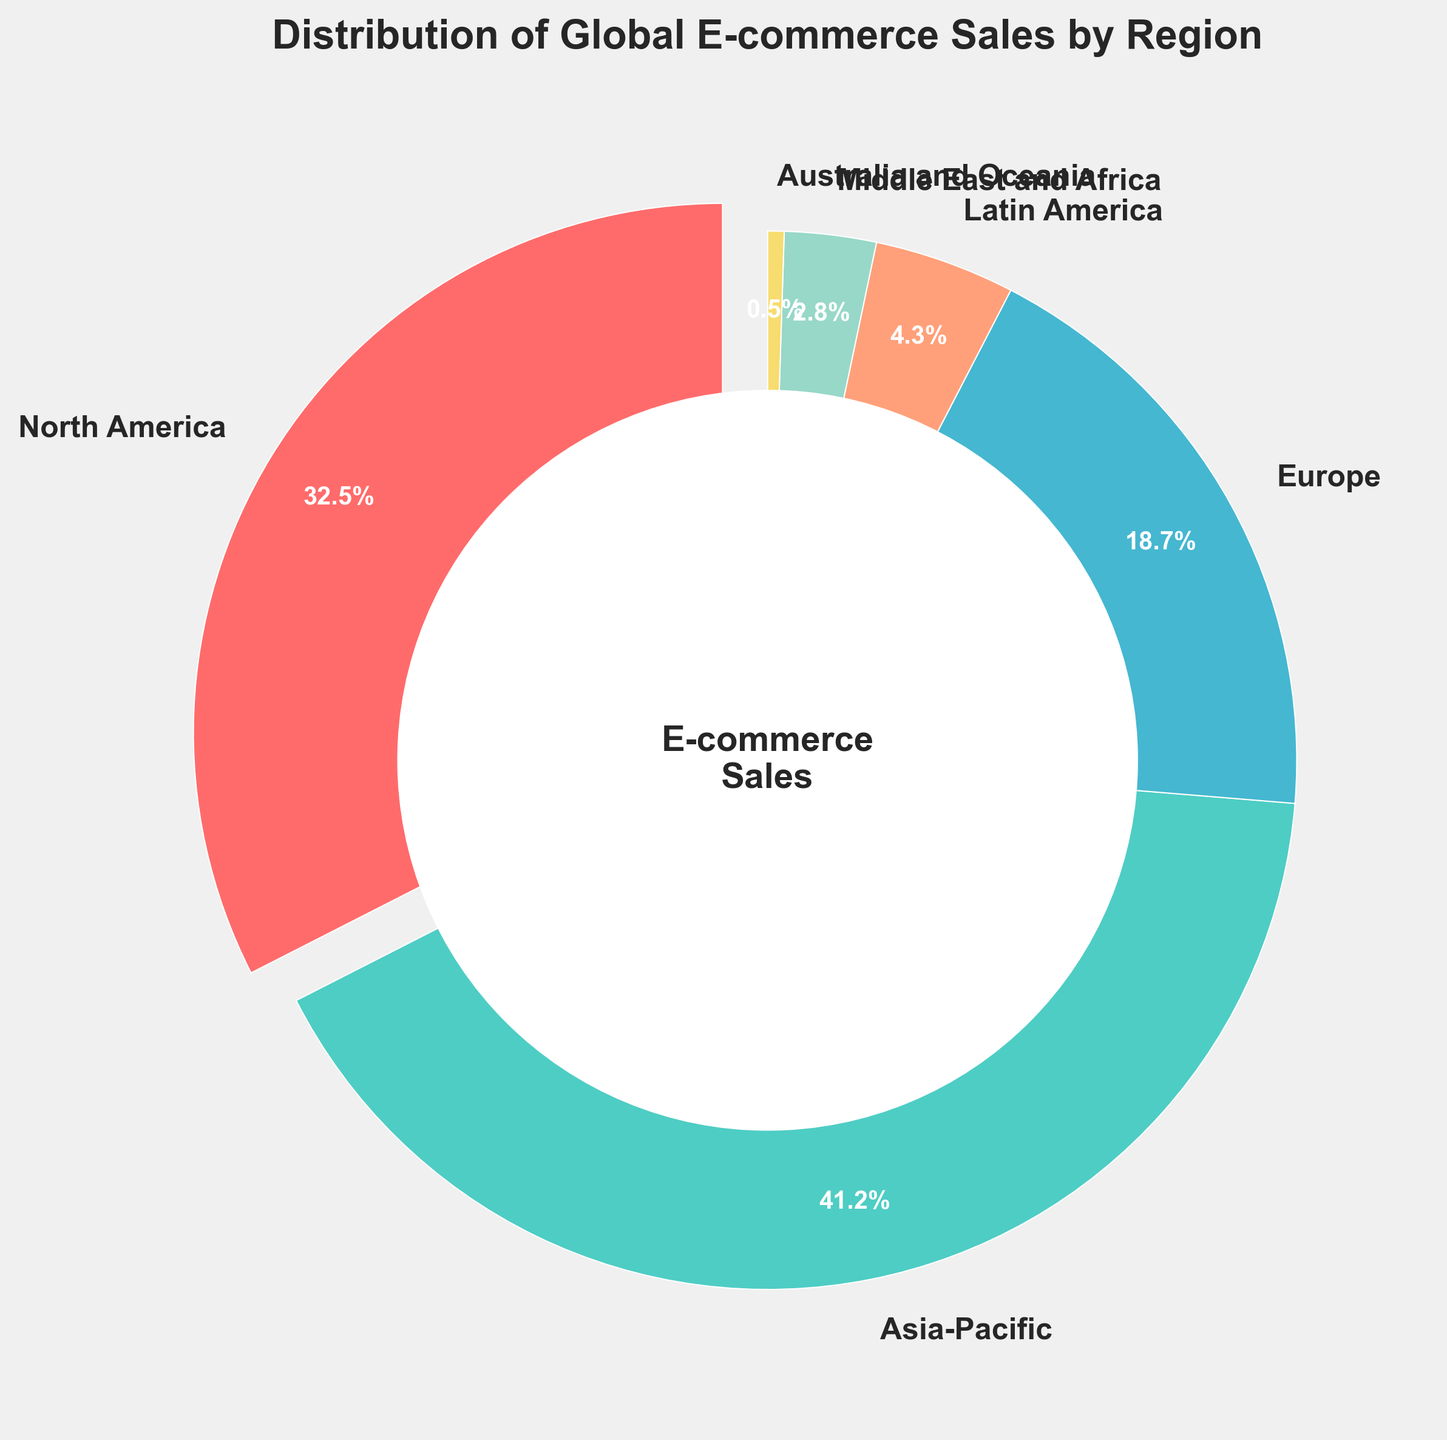Which region has the largest percentage of global e-commerce sales? The region with the largest slice of the pie chart is the one with the largest percentage. The slice representing Asia-Pacific is the largest.
Answer: Asia-Pacific Which regions together make up more than 50% of global e-commerce sales? Adding the percentages, Asia-Pacific (41.2%) and North America (32.5%) together sum to 73.7%, which is more than 50%.
Answer: Asia-Pacific and North America How much more percentage does Asia-Pacific have compared to Europe? Subtracting Europe's percentage from Asia-Pacific's, 41.2% - 18.7% = 22.5%.
Answer: 22.5% What is the total percentage of global e-commerce sales for Latin America, the Middle East and Africa, and Australia and Oceania? Adding the percentages of Latin America (4.3%), the Middle East and Africa (2.8%), and Australia and Oceania (0.5%), the total is 4.3% + 2.8% + 0.5% = 7.6%.
Answer: 7.6% Rank the regions from highest to lowest based on their percentage of global e-commerce sales. Observing the sizes of the pie chart slices and their associated percentages: Asia-Pacific (41.2%), North America (32.5%), Europe (18.7%), Latin America (4.3%), Middle East and Africa (2.8%), Australia and Oceania (0.5%).
Answer: Asia-Pacific, North America, Europe, Latin America, Middle East and Africa, Australia and Oceania Which three regions have the smallest percentages of global e-commerce sales? Looking at the smallest slices of the pie chart: Australia and Oceania (0.5%), Middle East and Africa (2.8%), and Latin America (4.3%).
Answer: Australia and Oceania, Middle East and Africa, Latin America What is the combined percentage of global e-commerce sales for North America and Europe? Adding North America's percentage (32.5%) and Europe's percentage (18.7%), the total is 32.5% + 18.7% = 51.2%.
Answer: 51.2% What color represents Latin America's percentage in the pie chart? The wedge for Latin America is in the color that matches its label on the chart. Latin America is represented by an orange-like color.
Answer: Orange 